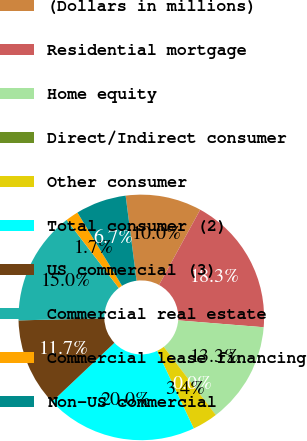<chart> <loc_0><loc_0><loc_500><loc_500><pie_chart><fcel>(Dollars in millions)<fcel>Residential mortgage<fcel>Home equity<fcel>Direct/Indirect consumer<fcel>Other consumer<fcel>Total consumer (2)<fcel>US commercial (3)<fcel>Commercial real estate<fcel>Commercial lease financing<fcel>Non-US commercial<nl><fcel>10.0%<fcel>18.31%<fcel>13.33%<fcel>0.02%<fcel>3.35%<fcel>19.98%<fcel>11.66%<fcel>14.99%<fcel>1.69%<fcel>6.67%<nl></chart> 